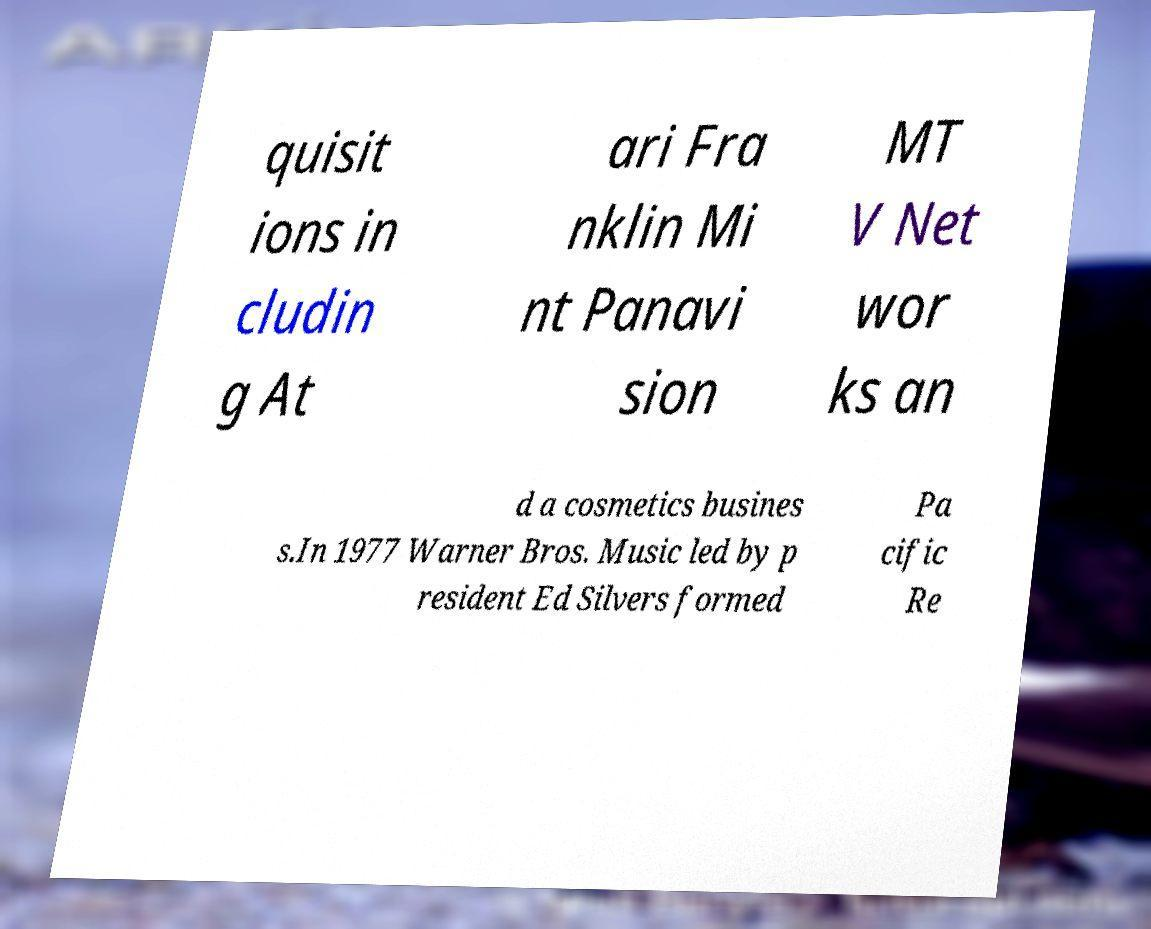Can you accurately transcribe the text from the provided image for me? quisit ions in cludin g At ari Fra nklin Mi nt Panavi sion MT V Net wor ks an d a cosmetics busines s.In 1977 Warner Bros. Music led by p resident Ed Silvers formed Pa cific Re 